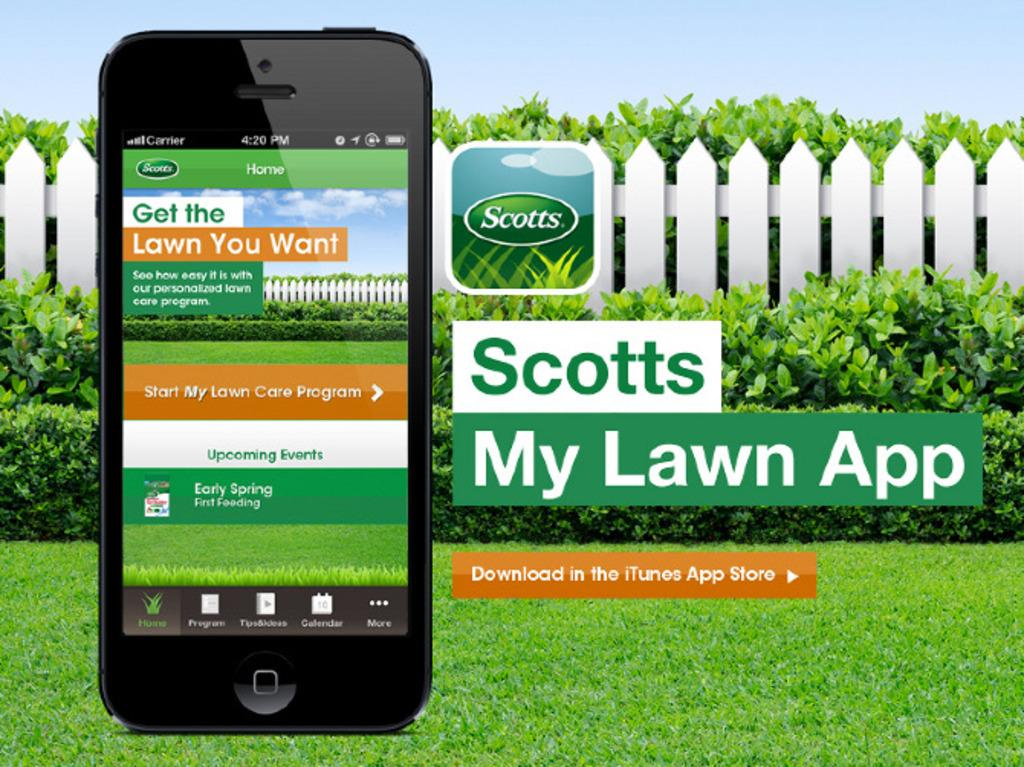What object can be seen in the image? There is a mobile in the image. What else is present on the mobile? There is text or writing on the image. What can be seen in the background of the image? There is fencing, the sky, and plants in green color in the background of the image. What type of pie is being served in the image? There is no pie present in the image. What month is it in the image? The image does not provide any information about the month or time of year. 